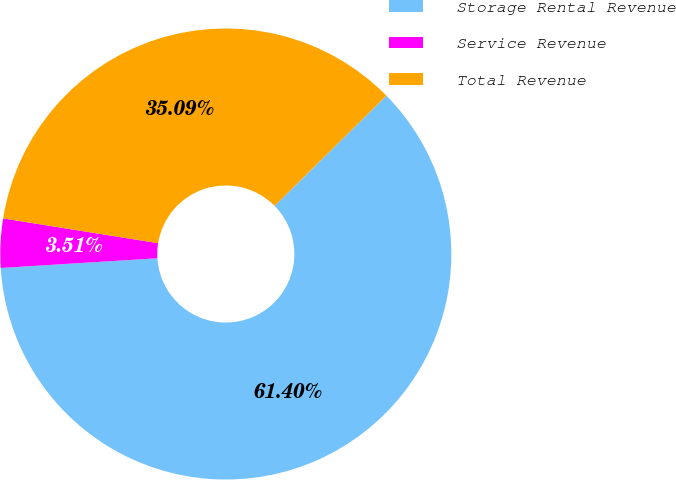Convert chart to OTSL. <chart><loc_0><loc_0><loc_500><loc_500><pie_chart><fcel>Storage Rental Revenue<fcel>Service Revenue<fcel>Total Revenue<nl><fcel>61.4%<fcel>3.51%<fcel>35.09%<nl></chart> 